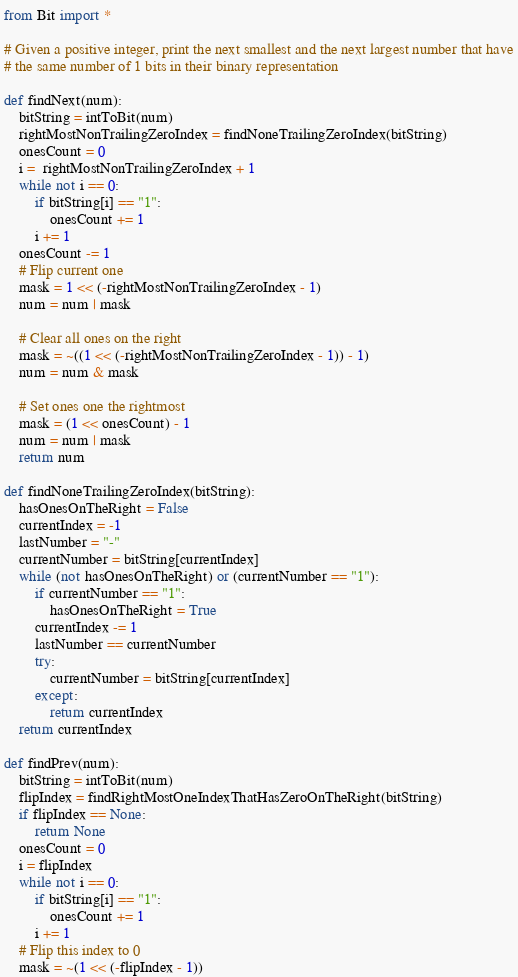Convert code to text. <code><loc_0><loc_0><loc_500><loc_500><_Python_>from Bit import *

# Given a positive integer, print the next smallest and the next largest number that have
# the same number of 1 bits in their binary representation

def findNext(num):
	bitString = intToBit(num)
	rightMostNonTrailingZeroIndex = findNoneTrailingZeroIndex(bitString)
	onesCount = 0
	i =  rightMostNonTrailingZeroIndex + 1
	while not i == 0:
		if bitString[i] == "1":
			onesCount += 1
		i += 1
	onesCount -= 1
	# Flip current one
	mask = 1 << (-rightMostNonTrailingZeroIndex - 1)
	num = num | mask

	# Clear all ones on the right
	mask = ~((1 << (-rightMostNonTrailingZeroIndex - 1)) - 1)
	num = num & mask

	# Set ones one the rightmost
	mask = (1 << onesCount) - 1
	num = num | mask
	return num

def findNoneTrailingZeroIndex(bitString):
	hasOnesOnTheRight = False
	currentIndex = -1
	lastNumber = "-"
	currentNumber = bitString[currentIndex]
	while (not hasOnesOnTheRight) or (currentNumber == "1"):
		if currentNumber == "1":
			hasOnesOnTheRight = True
		currentIndex -= 1
		lastNumber == currentNumber
		try:
			currentNumber = bitString[currentIndex]
		except:
			return currentIndex
	return currentIndex

def findPrev(num):
	bitString = intToBit(num)
	flipIndex = findRightMostOneIndexThatHasZeroOnTheRight(bitString)
	if flipIndex == None:
		return None
	onesCount = 0
	i = flipIndex
	while not i == 0:
		if bitString[i] == "1":
			onesCount += 1
		i += 1
	# Flip this index to 0
	mask = ~(1 << (-flipIndex - 1))</code> 